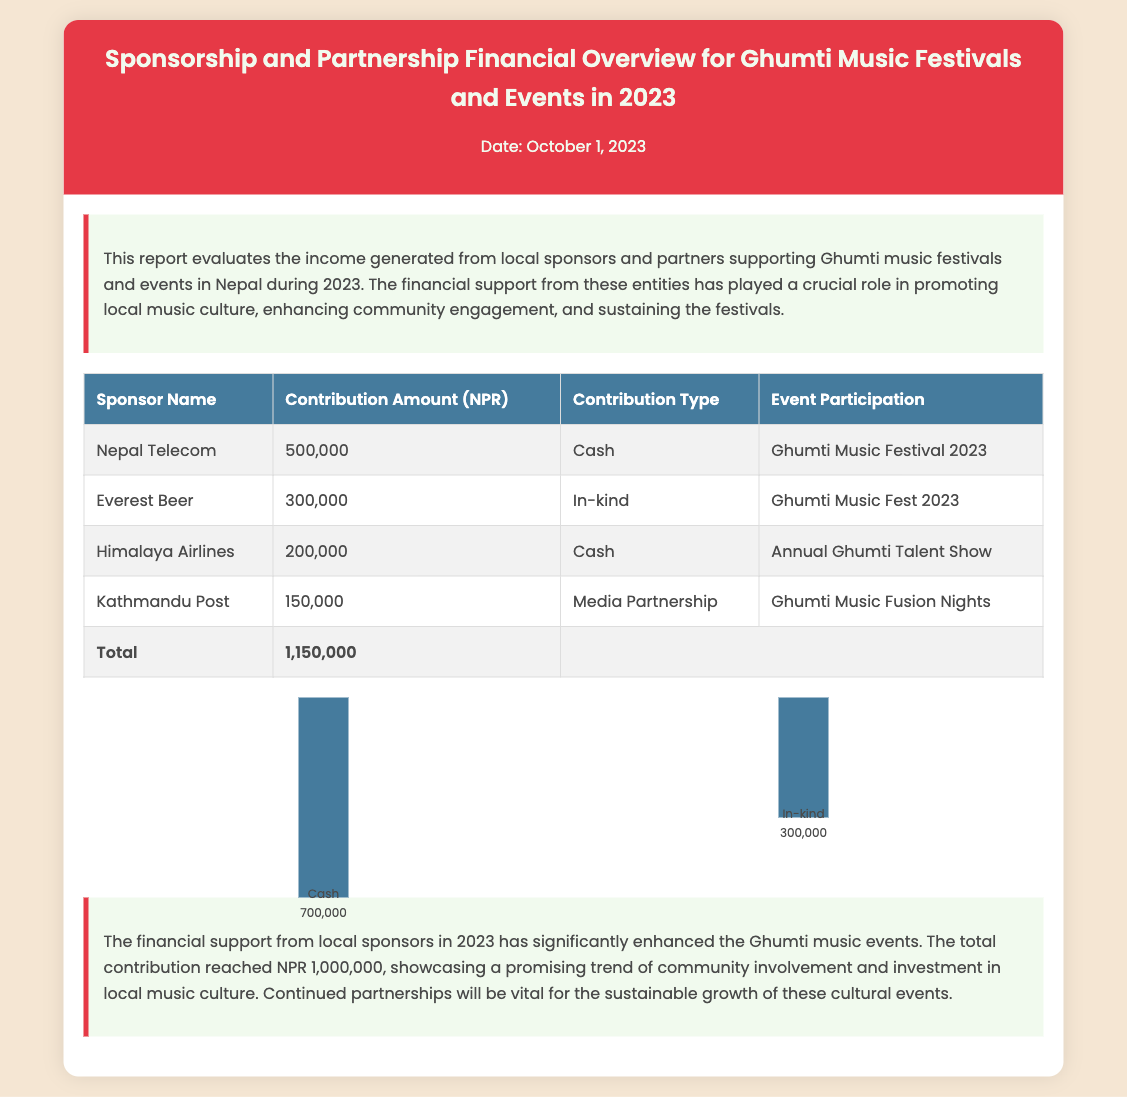What is the title of the report? The title of the report is found in the header section of the document.
Answer: Sponsorship and Partnership Financial Overview for Ghumti Music Festivals and Events in 2023 What is the total contribution amount from sponsors? The total contribution is calculated at the bottom of the table in the document.
Answer: 1,150,000 Which company contributed in cash for the Ghumti Music Festival 2023? This information is specified in the table under the respective event and contribution type.
Answer: Nepal Telecom What was the contribution type of Everest Beer? The type of contribution made by each sponsor is detailed in the table.
Answer: In-kind How much did Himalaya Airlines contribute? The contribution amount for each sponsor is listed in the table.
Answer: 200,000 What percentage of the total contribution was cash? The total cash contribution is compared to the overall contribution amount in the document.
Answer: 60.87% What event did Kathmandu Post participate in? The event participation by each sponsor is indicated in the table.
Answer: Ghumti Music Fusion Nights What is emphasized as vital for sustainable growth? The conclusion section highlights essential factors for the future of events.
Answer: Continued partnerships How many distinct sponsors are listed in the document? The total number of sponsors can be counted from the entries in the table.
Answer: 4 